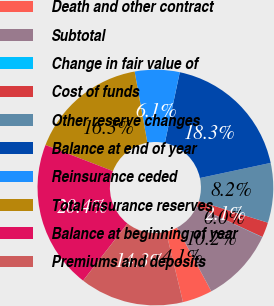Convert chart to OTSL. <chart><loc_0><loc_0><loc_500><loc_500><pie_chart><fcel>Death and other contract<fcel>Subtotal<fcel>Change in fair value of<fcel>Cost of funds<fcel>Other reserve changes<fcel>Balance at end of year<fcel>Reinsurance ceded<fcel>Total insurance reserves<fcel>Balance at beginning of year<fcel>Premiums and deposits<nl><fcel>4.11%<fcel>10.2%<fcel>0.04%<fcel>2.07%<fcel>8.17%<fcel>18.33%<fcel>6.14%<fcel>16.3%<fcel>20.37%<fcel>14.27%<nl></chart> 